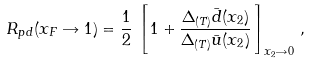<formula> <loc_0><loc_0><loc_500><loc_500>R _ { p d } ( x _ { F } \rightarrow 1 ) = \frac { 1 } { 2 } \, \left [ \, 1 + \frac { \Delta _ { ( T ) } \bar { d } ( x _ { 2 } ) } { \Delta _ { ( T ) } \bar { u } ( x _ { 2 } ) } \, \right ] _ { x _ { 2 } \rightarrow 0 } \, ,</formula> 